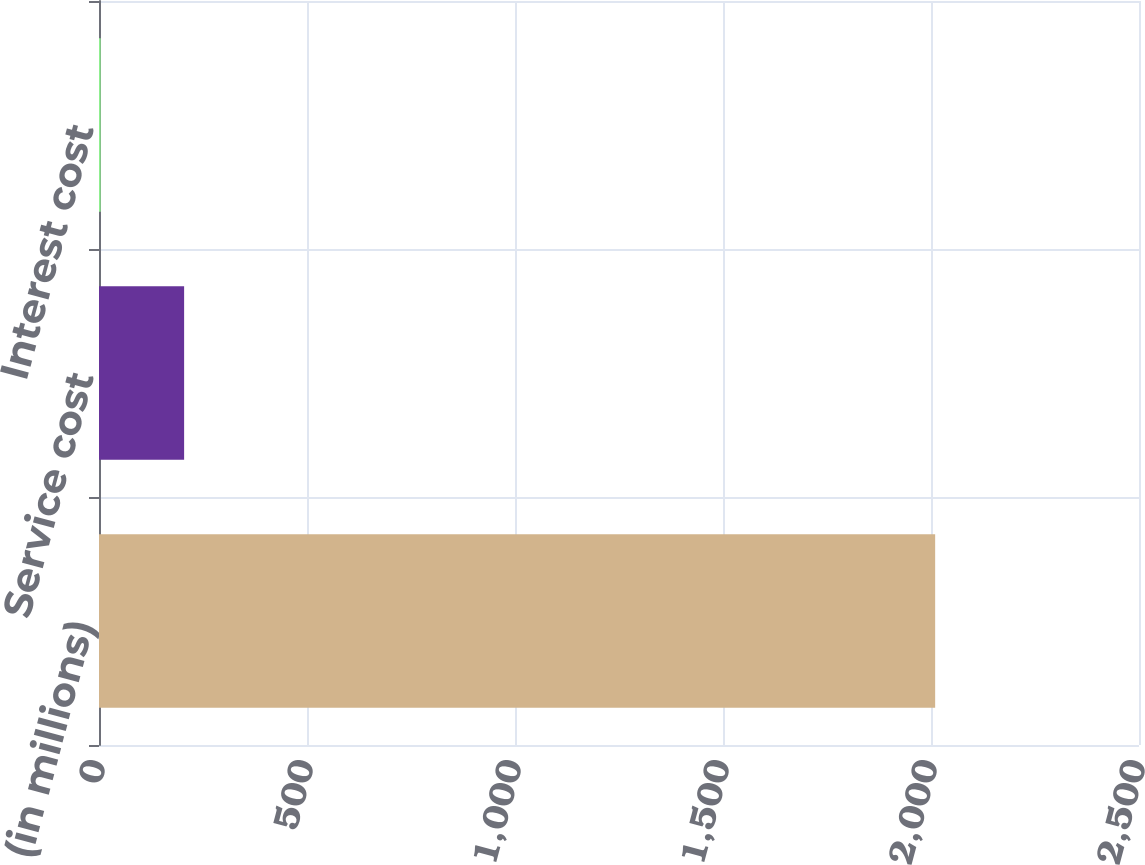Convert chart. <chart><loc_0><loc_0><loc_500><loc_500><bar_chart><fcel>(in millions)<fcel>Service cost<fcel>Interest cost<nl><fcel>2010<fcel>204.6<fcel>4<nl></chart> 